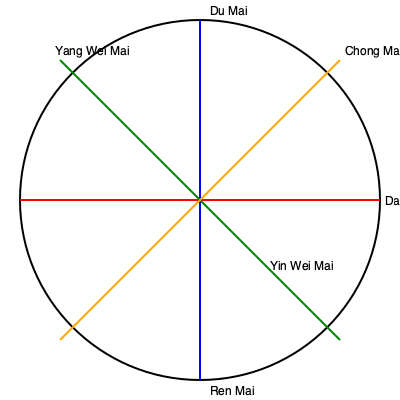In the context of energy healing and meridian theory, which of the extraordinary vessels shown in the diagram is responsible for governing the flow of energy along the spine and is often associated with spiritual development in yoga practices? To answer this question, we need to understand the roles of the extraordinary vessels depicted in the diagram and their significance in energy healing and yoga practices:

1. Du Mai (Governor Vessel): This is the blue vertical line running from top to bottom. It runs along the spine from the tailbone to the top of the head and back down to the upper lip. In energy healing and yoga, it's associated with spiritual development and governs the flow of energy along the spine.

2. Ren Mai (Conception Vessel): This is the other end of the blue vertical line. It runs from the perineum up the front of the body to the lower lip. While important, it's not specifically associated with spinal energy flow.

3. Dai Mai (Belt Vessel): This is the red horizontal line. It circles the waist and is not directly related to spinal energy flow or spiritual development in yoga.

4. Chong Mai (Penetrating Vessel): This is one of the diagonal lines. While important in overall energy circulation, it's not specifically associated with spinal energy or spiritual development in yoga practices.

5. Yang Wei Mai and Yin Wei Mai: These are the other diagonal lines. They are involved in regulating the balance between yin and yang energies but are not directly associated with spinal energy flow or spiritual development in yoga.

Given the question's focus on spinal energy flow and spiritual development in yoga practices, the Du Mai (Governor Vessel) is the most relevant answer. It's the primary channel for governing the flow of energy along the spine and is often worked with in yoga and meditation practices for spiritual growth and kundalini awakening.
Answer: Du Mai (Governor Vessel) 